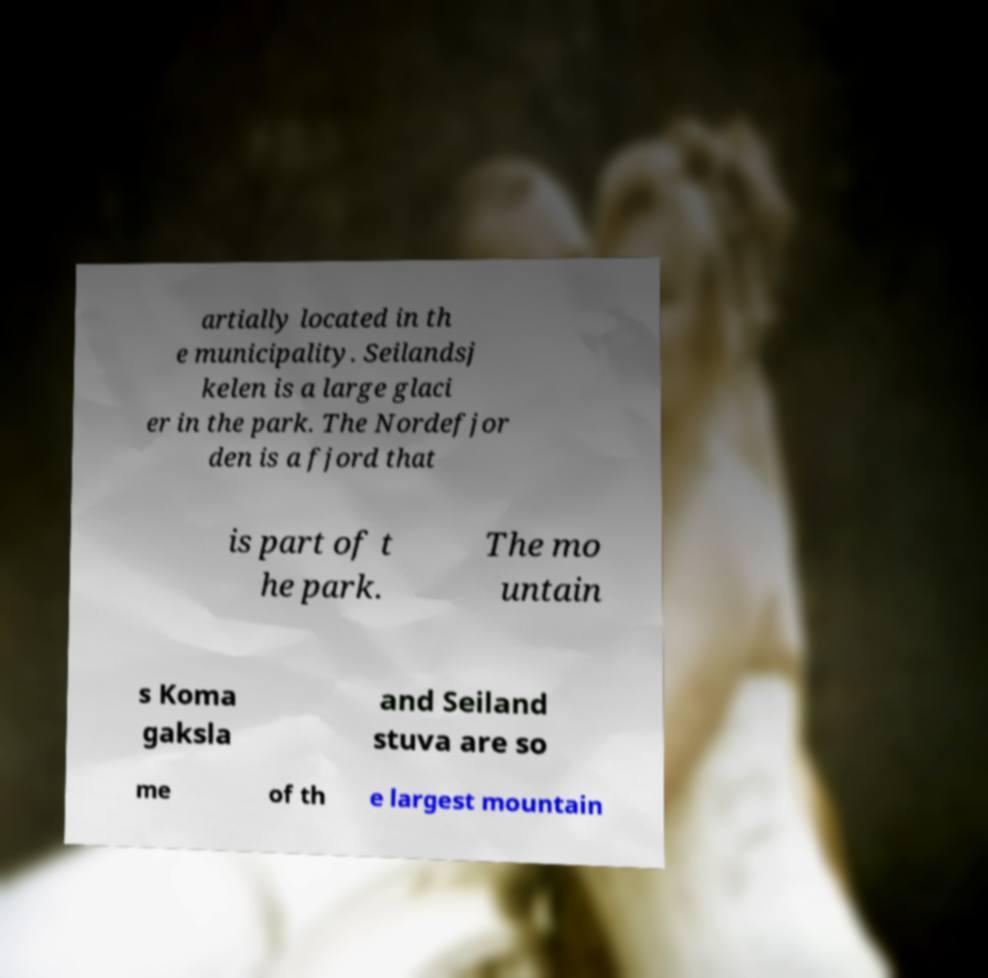Please read and relay the text visible in this image. What does it say? artially located in th e municipality. Seilandsj kelen is a large glaci er in the park. The Nordefjor den is a fjord that is part of t he park. The mo untain s Koma gaksla and Seiland stuva are so me of th e largest mountain 